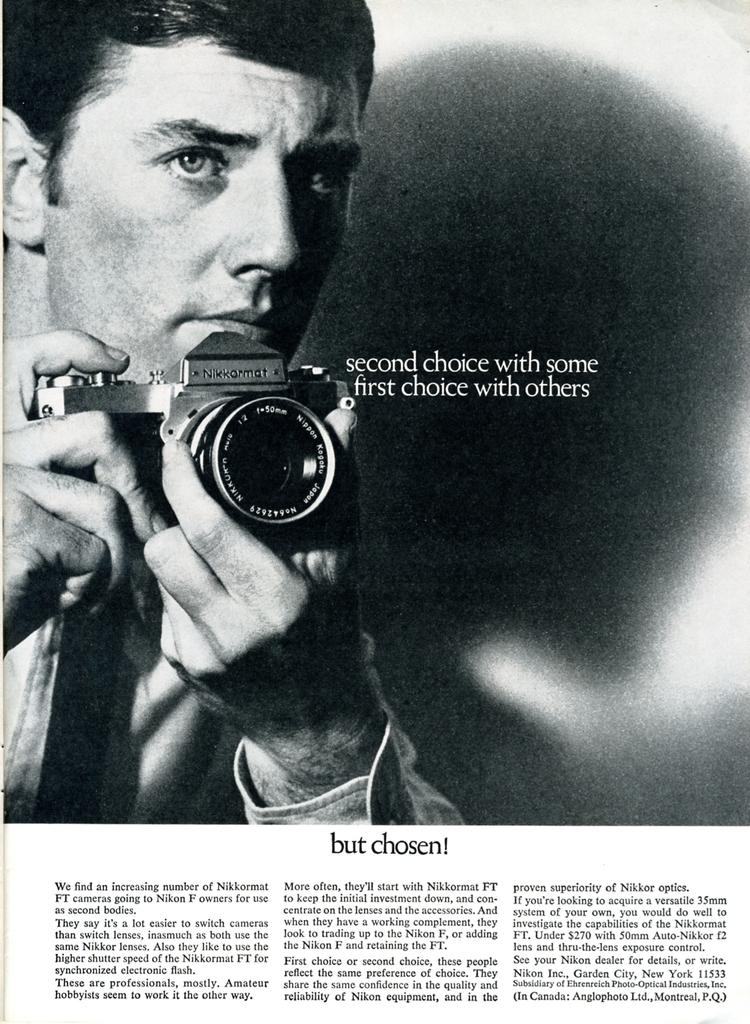What is the main subject of the image? The main subject of the image is a man. What is the man wearing in the image? The man is wearing a white shirt and a black tie in the image. What is the man holding in the image? The man is holding a camera in the image. What is the man doing in the image? The man is posing for a photograph in the image. What type of feather can be seen on the man's hat in the image? There is no hat or feather present in the image; the man is wearing a white shirt and a black tie. What flavor of jelly is the man eating in the image? There is no jelly or eating activity present in the image; the man is holding a camera and posing for a photograph. 